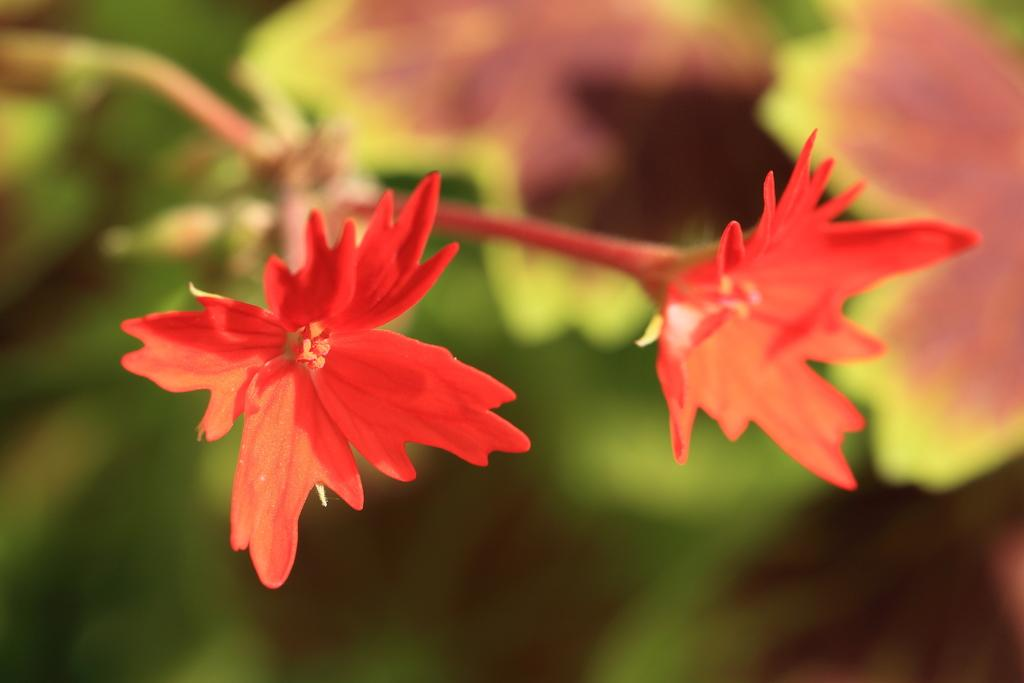What type of plants can be seen in the image? There are flowers in the image. What color is the background of the image? The background of the image is blue. What type of comparison can be made between the flowers and the spoon in the image? There is no spoon present in the image, so no comparison can be made between the flowers and a spoon. 